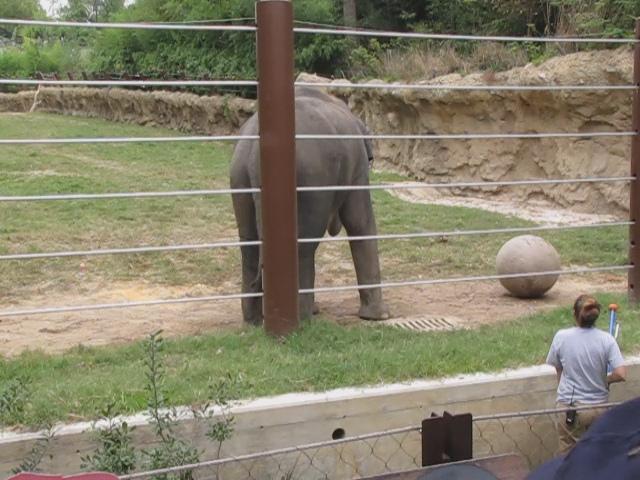How will she tell her supervisor about the welfare of the animal?
Make your selection from the four choices given to correctly answer the question.
Options: Walkie talkie, flare, shouting, text message. Walkie talkie. 